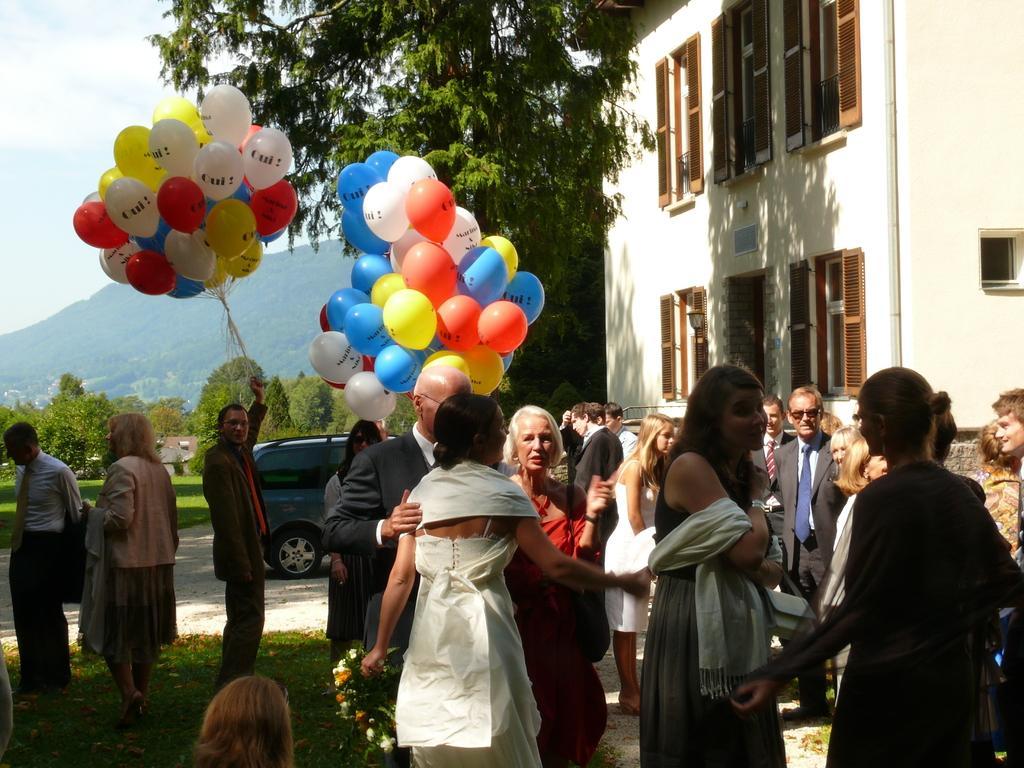How would you summarize this image in a sentence or two? In this image there are people standing few are holding balloons, in the background there is a car, trees, mountain and the sky, in the top right there is a building. 